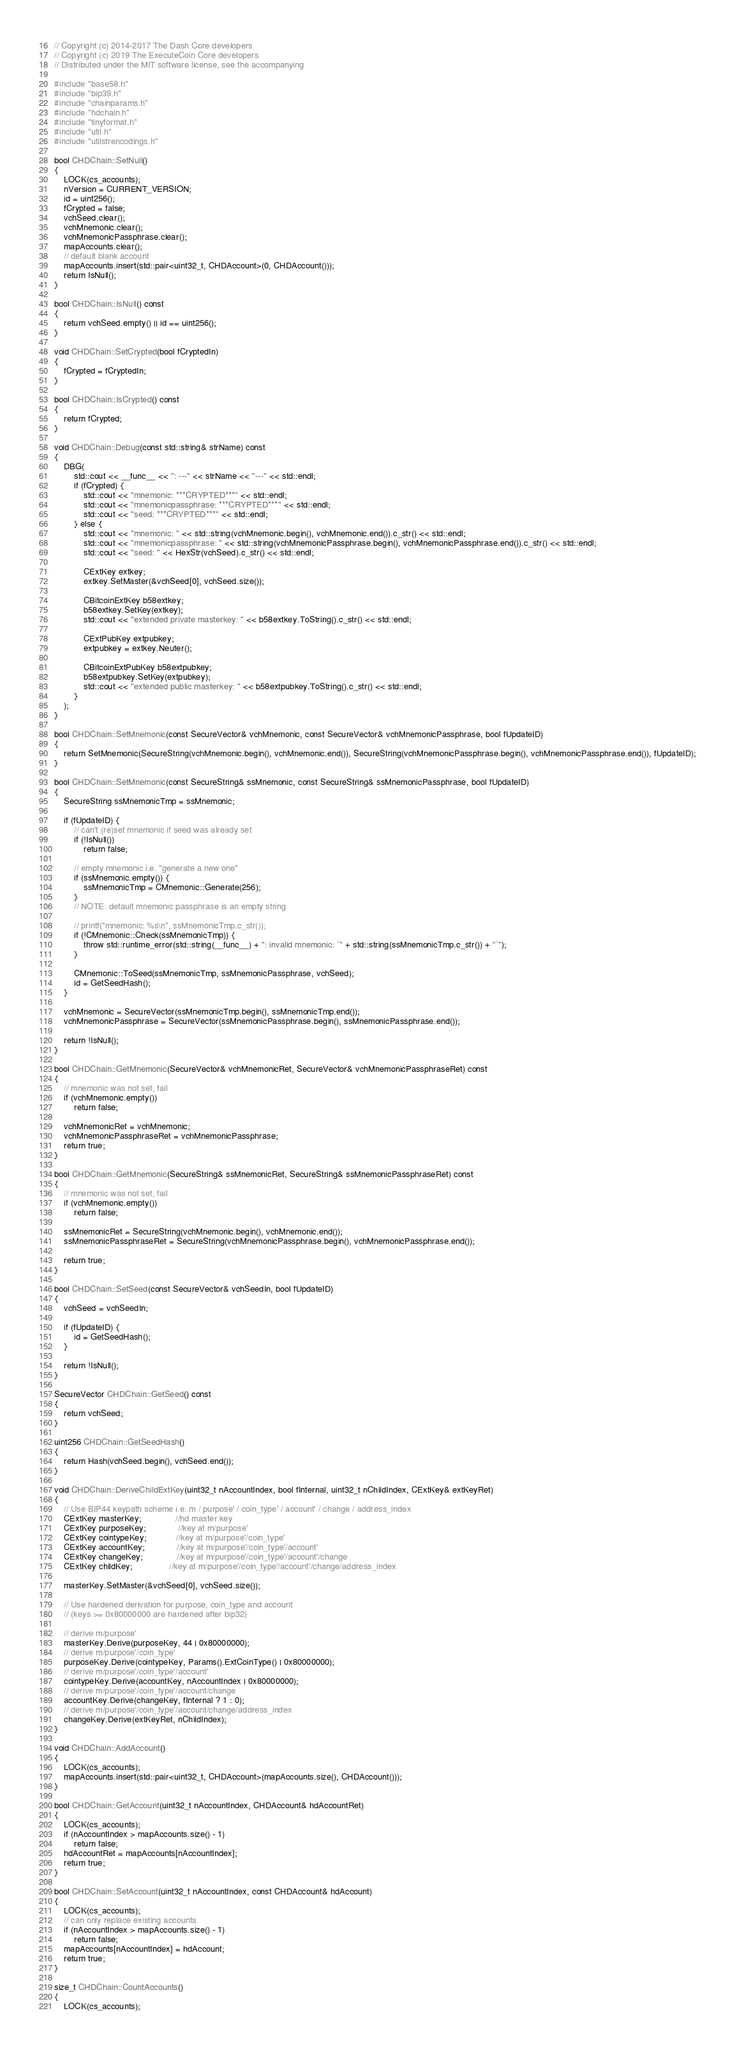<code> <loc_0><loc_0><loc_500><loc_500><_C++_>// Copyright (c) 2014-2017 The Dash Core developers
// Copyright (c) 2019 The ExecuteCoin Core developers
// Distributed under the MIT software license, see the accompanying

#include "base58.h"
#include "bip39.h"
#include "chainparams.h"
#include "hdchain.h"
#include "tinyformat.h"
#include "util.h"
#include "utilstrencodings.h"

bool CHDChain::SetNull()
{
    LOCK(cs_accounts);
    nVersion = CURRENT_VERSION;
    id = uint256();
    fCrypted = false;
    vchSeed.clear();
    vchMnemonic.clear();
    vchMnemonicPassphrase.clear();
    mapAccounts.clear();
    // default blank account
    mapAccounts.insert(std::pair<uint32_t, CHDAccount>(0, CHDAccount()));
    return IsNull();
}

bool CHDChain::IsNull() const
{
    return vchSeed.empty() || id == uint256();
}

void CHDChain::SetCrypted(bool fCryptedIn)
{
    fCrypted = fCryptedIn;
}

bool CHDChain::IsCrypted() const
{
    return fCrypted;
}

void CHDChain::Debug(const std::string& strName) const
{
    DBG(
        std::cout << __func__ << ": ---" << strName << "---" << std::endl;
        if (fCrypted) {
            std::cout << "mnemonic: ***CRYPTED***" << std::endl;
            std::cout << "mnemonicpassphrase: ***CRYPTED***" << std::endl;
            std::cout << "seed: ***CRYPTED***" << std::endl;
        } else {
            std::cout << "mnemonic: " << std::string(vchMnemonic.begin(), vchMnemonic.end()).c_str() << std::endl;
            std::cout << "mnemonicpassphrase: " << std::string(vchMnemonicPassphrase.begin(), vchMnemonicPassphrase.end()).c_str() << std::endl;
            std::cout << "seed: " << HexStr(vchSeed).c_str() << std::endl;

            CExtKey extkey;
            extkey.SetMaster(&vchSeed[0], vchSeed.size());

            CBitcoinExtKey b58extkey;
            b58extkey.SetKey(extkey);
            std::cout << "extended private masterkey: " << b58extkey.ToString().c_str() << std::endl;

            CExtPubKey extpubkey;
            extpubkey = extkey.Neuter();

            CBitcoinExtPubKey b58extpubkey;
            b58extpubkey.SetKey(extpubkey);
            std::cout << "extended public masterkey: " << b58extpubkey.ToString().c_str() << std::endl;
        }
    );
}

bool CHDChain::SetMnemonic(const SecureVector& vchMnemonic, const SecureVector& vchMnemonicPassphrase, bool fUpdateID)
{
    return SetMnemonic(SecureString(vchMnemonic.begin(), vchMnemonic.end()), SecureString(vchMnemonicPassphrase.begin(), vchMnemonicPassphrase.end()), fUpdateID);
}

bool CHDChain::SetMnemonic(const SecureString& ssMnemonic, const SecureString& ssMnemonicPassphrase, bool fUpdateID)
{
    SecureString ssMnemonicTmp = ssMnemonic;

    if (fUpdateID) {
        // can't (re)set mnemonic if seed was already set
        if (!IsNull())
            return false;

        // empty mnemonic i.e. "generate a new one"
        if (ssMnemonic.empty()) {
            ssMnemonicTmp = CMnemonic::Generate(256);
        }
        // NOTE: default mnemonic passphrase is an empty string

        // printf("mnemonic: %s\n", ssMnemonicTmp.c_str());
        if (!CMnemonic::Check(ssMnemonicTmp)) {
            throw std::runtime_error(std::string(__func__) + ": invalid mnemonic: `" + std::string(ssMnemonicTmp.c_str()) + "`");
        }

        CMnemonic::ToSeed(ssMnemonicTmp, ssMnemonicPassphrase, vchSeed);
        id = GetSeedHash();
    }

    vchMnemonic = SecureVector(ssMnemonicTmp.begin(), ssMnemonicTmp.end());
    vchMnemonicPassphrase = SecureVector(ssMnemonicPassphrase.begin(), ssMnemonicPassphrase.end());

    return !IsNull();
}

bool CHDChain::GetMnemonic(SecureVector& vchMnemonicRet, SecureVector& vchMnemonicPassphraseRet) const
{
    // mnemonic was not set, fail
    if (vchMnemonic.empty())
        return false;

    vchMnemonicRet = vchMnemonic;
    vchMnemonicPassphraseRet = vchMnemonicPassphrase;
    return true;
}

bool CHDChain::GetMnemonic(SecureString& ssMnemonicRet, SecureString& ssMnemonicPassphraseRet) const
{
    // mnemonic was not set, fail
    if (vchMnemonic.empty())
        return false;

    ssMnemonicRet = SecureString(vchMnemonic.begin(), vchMnemonic.end());
    ssMnemonicPassphraseRet = SecureString(vchMnemonicPassphrase.begin(), vchMnemonicPassphrase.end());

    return true;
}

bool CHDChain::SetSeed(const SecureVector& vchSeedIn, bool fUpdateID)
{
    vchSeed = vchSeedIn;

    if (fUpdateID) {
        id = GetSeedHash();
    }

    return !IsNull();
}

SecureVector CHDChain::GetSeed() const
{
    return vchSeed;
}

uint256 CHDChain::GetSeedHash()
{
    return Hash(vchSeed.begin(), vchSeed.end());
}

void CHDChain::DeriveChildExtKey(uint32_t nAccountIndex, bool fInternal, uint32_t nChildIndex, CExtKey& extKeyRet)
{
    // Use BIP44 keypath scheme i.e. m / purpose' / coin_type' / account' / change / address_index
    CExtKey masterKey;              //hd master key
    CExtKey purposeKey;             //key at m/purpose'
    CExtKey cointypeKey;            //key at m/purpose'/coin_type'
    CExtKey accountKey;             //key at m/purpose'/coin_type'/account'
    CExtKey changeKey;              //key at m/purpose'/coin_type'/account'/change
    CExtKey childKey;               //key at m/purpose'/coin_type'/account'/change/address_index

    masterKey.SetMaster(&vchSeed[0], vchSeed.size());

    // Use hardened derivation for purpose, coin_type and account
    // (keys >= 0x80000000 are hardened after bip32)

    // derive m/purpose'
    masterKey.Derive(purposeKey, 44 | 0x80000000);
    // derive m/purpose'/coin_type'
    purposeKey.Derive(cointypeKey, Params().ExtCoinType() | 0x80000000);
    // derive m/purpose'/coin_type'/account'
    cointypeKey.Derive(accountKey, nAccountIndex | 0x80000000);
    // derive m/purpose'/coin_type'/account/change
    accountKey.Derive(changeKey, fInternal ? 1 : 0);
    // derive m/purpose'/coin_type'/account/change/address_index
    changeKey.Derive(extKeyRet, nChildIndex);
}

void CHDChain::AddAccount()
{
    LOCK(cs_accounts);
    mapAccounts.insert(std::pair<uint32_t, CHDAccount>(mapAccounts.size(), CHDAccount()));
}

bool CHDChain::GetAccount(uint32_t nAccountIndex, CHDAccount& hdAccountRet)
{
    LOCK(cs_accounts);
    if (nAccountIndex > mapAccounts.size() - 1)
        return false;
    hdAccountRet = mapAccounts[nAccountIndex];
    return true;
}

bool CHDChain::SetAccount(uint32_t nAccountIndex, const CHDAccount& hdAccount)
{
    LOCK(cs_accounts);
    // can only replace existing accounts
    if (nAccountIndex > mapAccounts.size() - 1)
        return false;
    mapAccounts[nAccountIndex] = hdAccount;
    return true;
}

size_t CHDChain::CountAccounts()
{
    LOCK(cs_accounts);</code> 